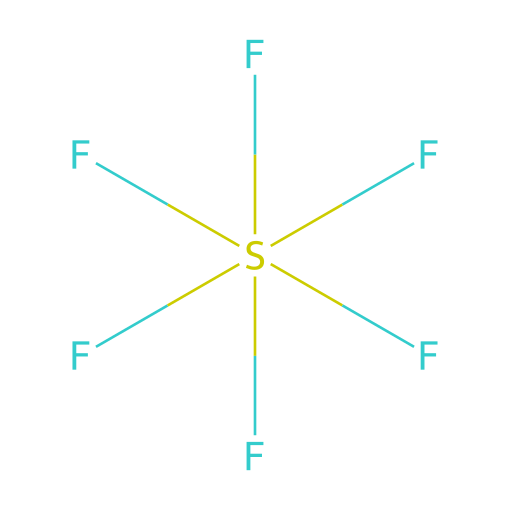What is the name of this chemical? The chemical is sulfur hexafluoride, which can be identified by the presence of one sulfur atom surrounded by six fluorine atoms in its structure.
Answer: sulfur hexafluoride How many fluorine atoms are present? By examining the structure, we can see there are six fluorine atoms connected to the central sulfur atom, as indicated by the six F atoms depicted.
Answer: six What type of bonding is present in this compound? The compound primarily exhibits covalent bonding, as the sulfur and fluorine atoms share electrons to form strong connections.
Answer: covalent Can this structure be classified as hypervalent? Yes, sulfur hexafluoride is hypervalent because the sulfur atom has more than four bonds, specifically six, which exceeds the typical octet rule for main group elements.
Answer: yes What is the hybridization of the sulfur atom? The sulfur atom in sulfur hexafluoride is sp3d2 hybridized, which accommodates the six bonding pairs present in the structure.
Answer: sp3d2 Is sulfur hexafluoride a gas at room temperature? Yes, sulfur hexafluoride is a gas at room temperature, as it has a low boiling point and exists in a gaseous state under normal conditions.
Answer: yes What is the primary use of sulfur hexafluoride in industry? The primary use of sulfur hexafluoride is in high-voltage electrical insulation due to its excellent dielectric properties, which prevent electrical discharge.
Answer: electrical insulation 